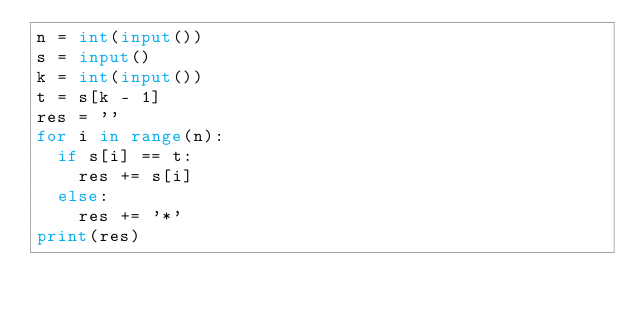<code> <loc_0><loc_0><loc_500><loc_500><_Python_>n = int(input())
s = input()
k = int(input())
t = s[k - 1]
res = ''
for i in range(n):
  if s[i] == t:
    res += s[i]
  else:
    res += '*'
print(res)</code> 